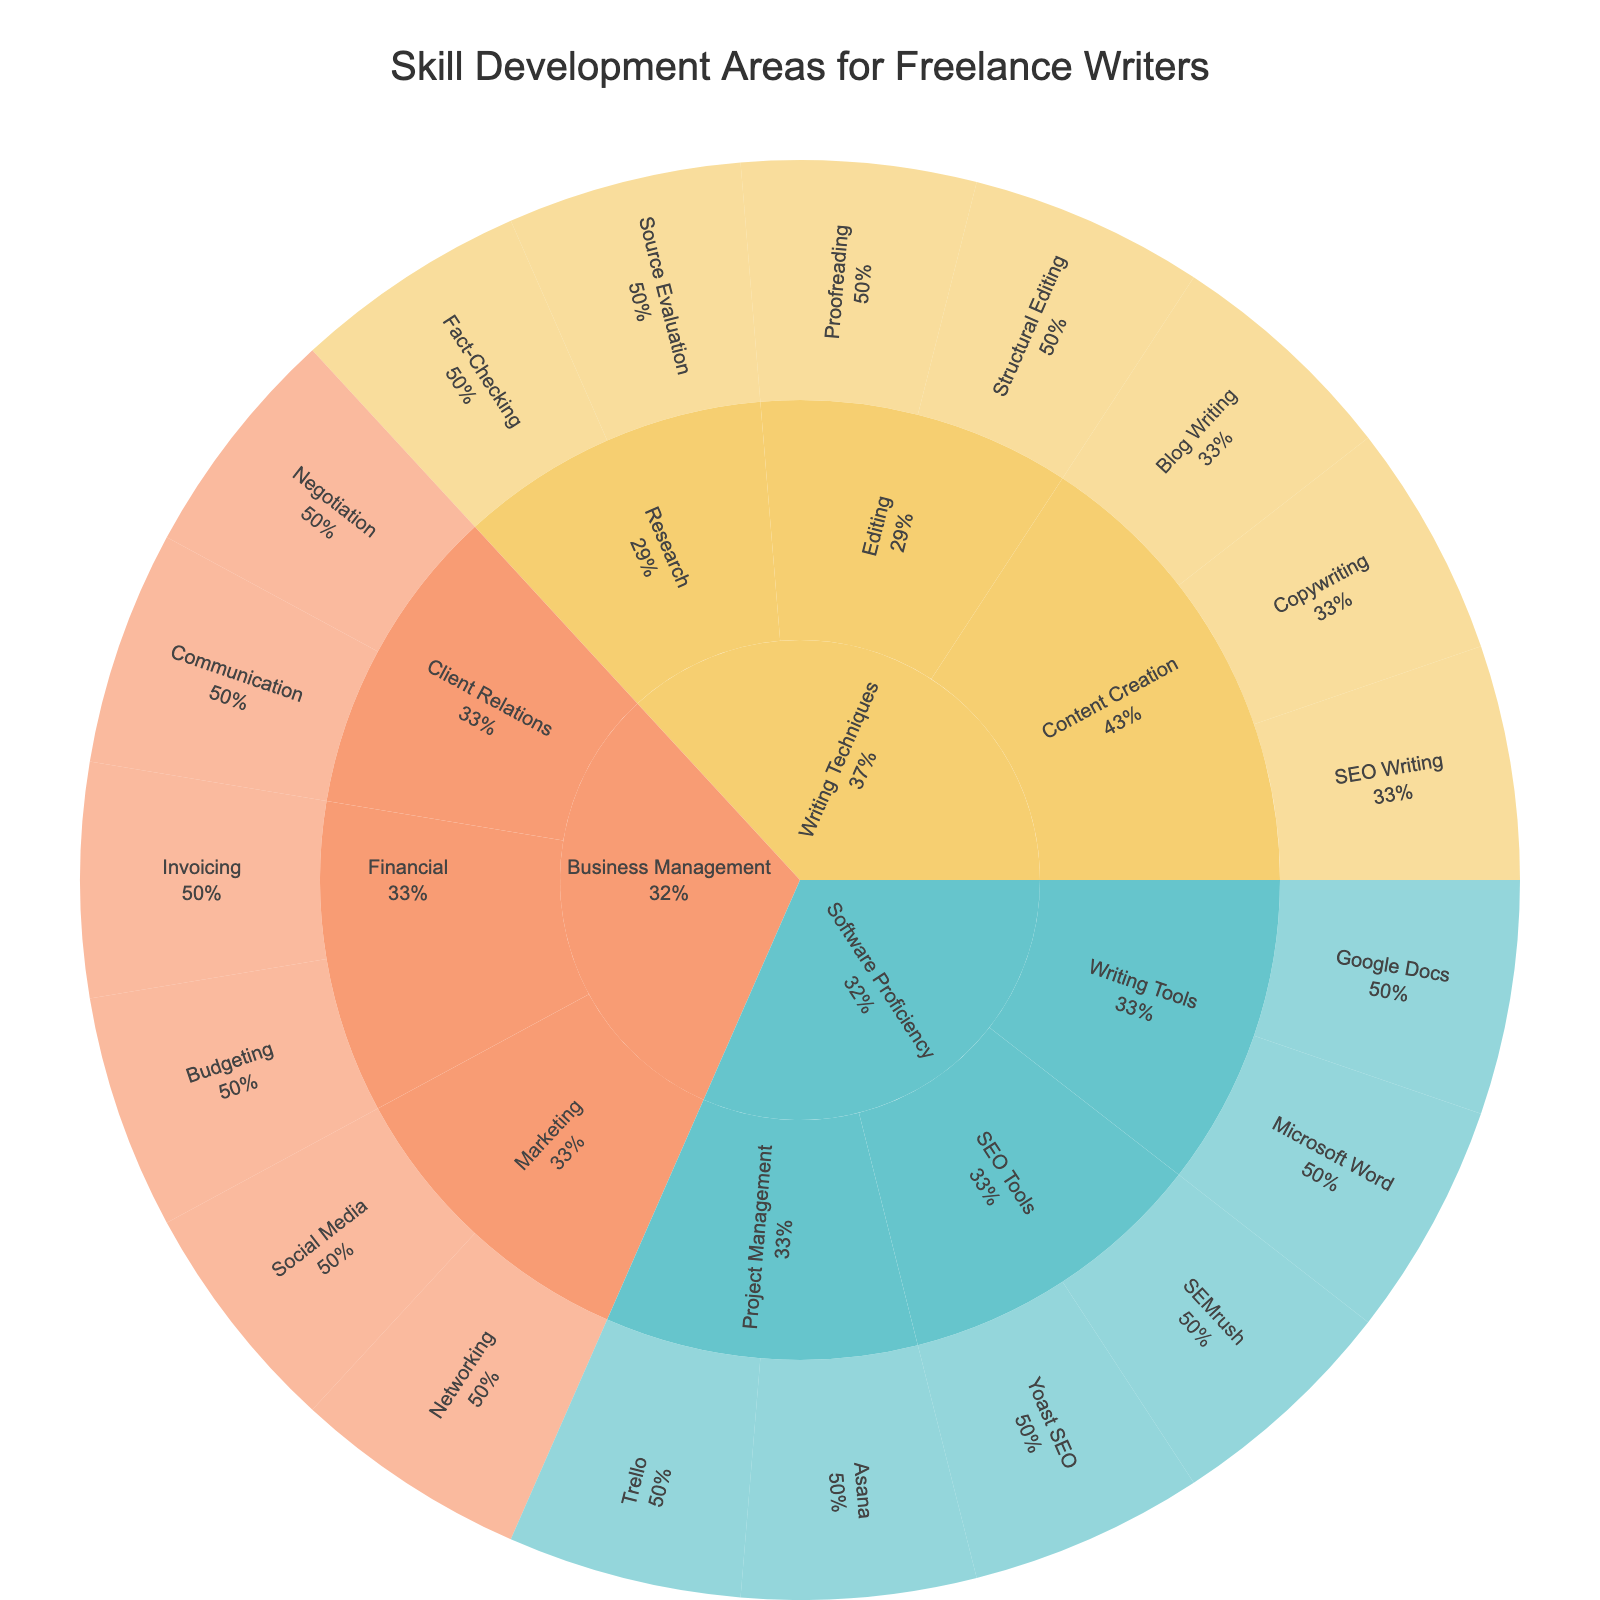What is the title of the figure? The title is typically placed at the top of the figure. Here, it's clearly marked to describe the content being visualized.
Answer: Skill Development Areas for Freelance Writers Which main category has the most subcategories? There are three main categories: Writing Techniques, Software Proficiency, and Business Management. By counting the number of subcategories for each, Writing Techniques has 3 subcategories, Software Proficiency has 3, and Business Management has 3, so they are all equal.
Answer: They all have an equal number of subcategories How many skills are under Business Management? The Business Management category has three subcategories: Client Relations, Financial, and Marketing. Counting the skills under each subcategory: Client Relations (2), Financial (2), and Marketing (2), the total is 2 + 2 + 2.
Answer: 6 Which subcategory has the skill "Proofreading"? Locate the skill "Proofreading" in the figure and trace back to its immediate parent subcategory.
Answer: Editing Are there more skills listed under Content Creation or SEO Tools? Count the number of skills under each subcategory: Content Creation (3), SEO Tools (2).
Answer: Content Creation What percentage of skills in Writing Techniques does Content Creation represent? First, identify how many skills are in Writing Techniques: Content Creation (3), Editing (2), Research (2), totaling 7 skills. Content Creation has 3 out of this 7. So, the percentage is (3/7) * 100%.
Answer: Approximately 42.86% Which main category includes "Invoicing"? Locate "Invoicing" and identify its immediate parent category.
Answer: Business Management Compare the number of skills in Project Management and Marketing. Which has more? Count the skills under Project Management (2) and Marketing (2) and compare.
Answer: They are equal What proportion of Software Proficiency is related to Writing Tools? Count the total number of skills under Software Proficiency (6) and the number of skills under Writing Tools (2). The proportion is (2/6).
Answer: Approximately 33.33% Which main category has a subcategory with only two listed skills? By visually scanning the subcategories under each main category, we see that the main categories with subcategories having exactly two skills are Software Proficiency (Writing Tools) and Business Management (all subcategories).
Answer: Software Proficiency and Business Management 